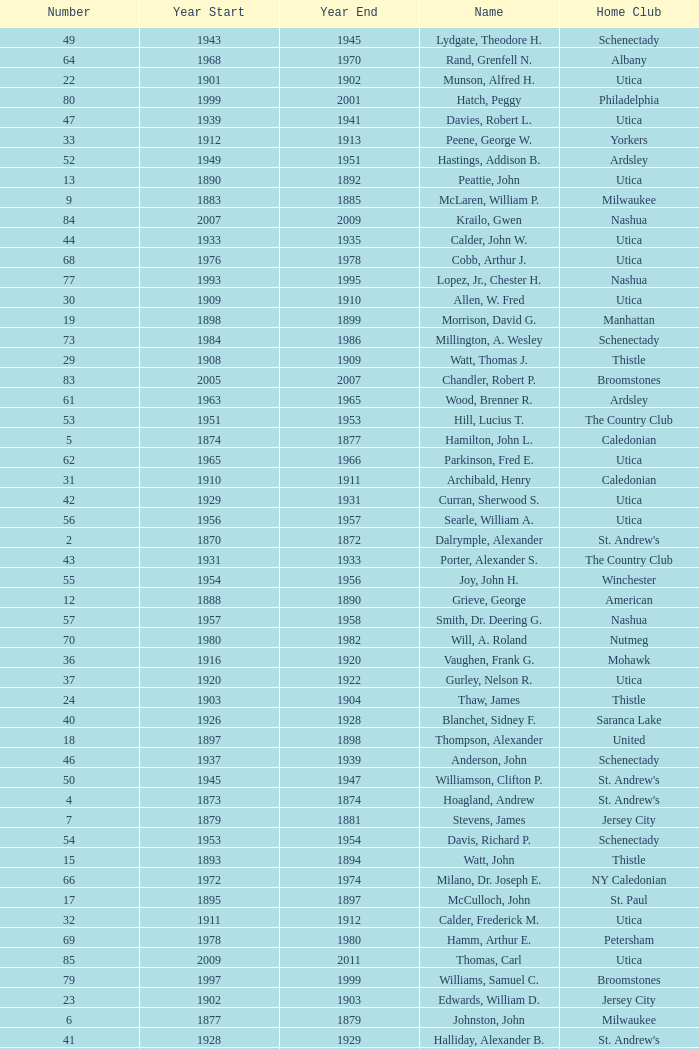Which Number has a Name of hill, lucius t.? 53.0. 